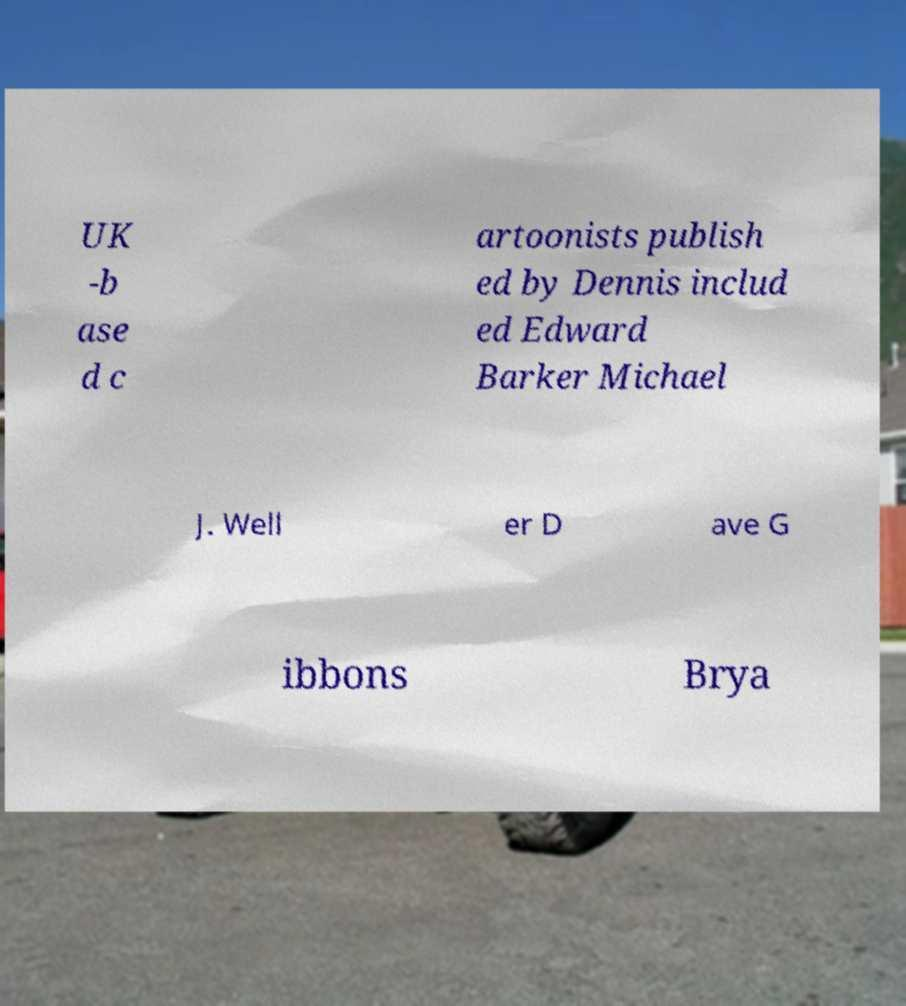Could you assist in decoding the text presented in this image and type it out clearly? UK -b ase d c artoonists publish ed by Dennis includ ed Edward Barker Michael J. Well er D ave G ibbons Brya 